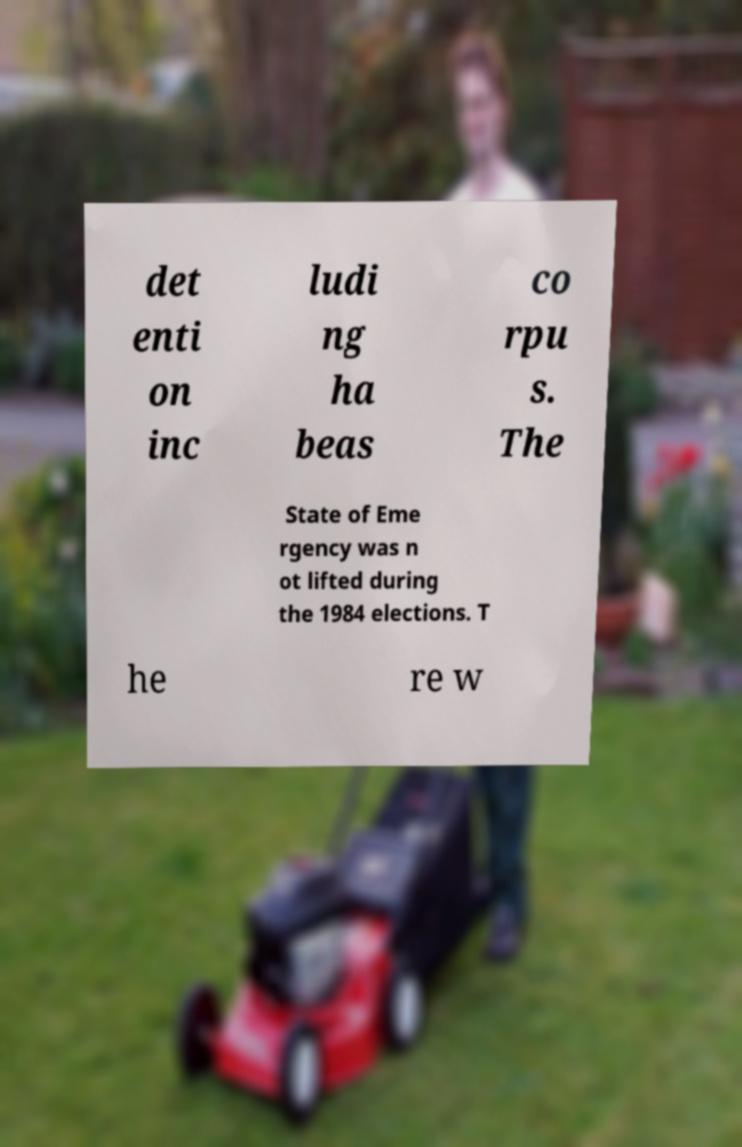Please read and relay the text visible in this image. What does it say? det enti on inc ludi ng ha beas co rpu s. The State of Eme rgency was n ot lifted during the 1984 elections. T he re w 